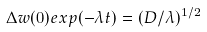<formula> <loc_0><loc_0><loc_500><loc_500>\Delta w ( 0 ) e x p ( - \lambda t ) = ( D / \lambda ) ^ { 1 / 2 }</formula> 